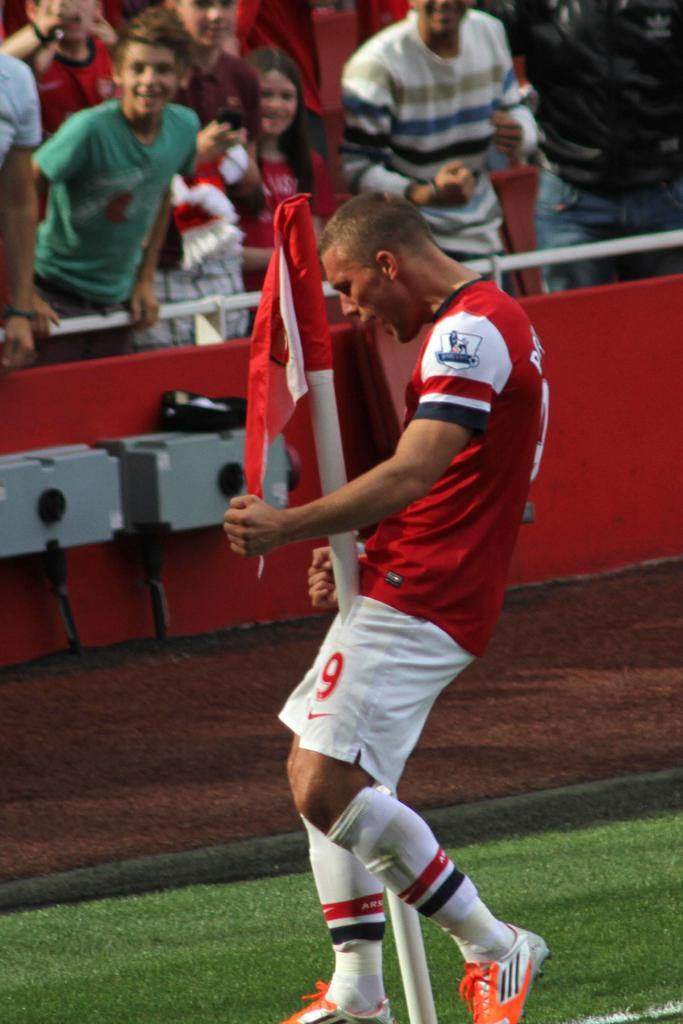Please provide a concise description of this image. In this image I can see a person. There is a pole with flag. And in the background there are group of people and some other objects. 